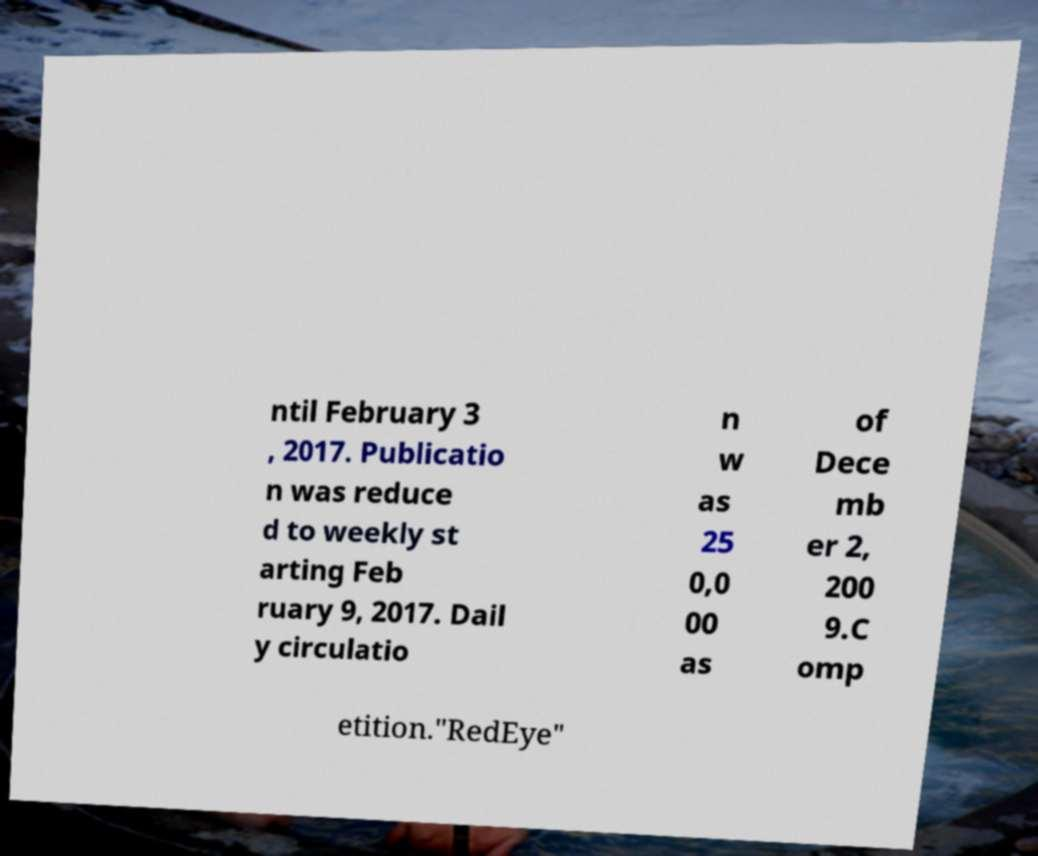For documentation purposes, I need the text within this image transcribed. Could you provide that? ntil February 3 , 2017. Publicatio n was reduce d to weekly st arting Feb ruary 9, 2017. Dail y circulatio n w as 25 0,0 00 as of Dece mb er 2, 200 9.C omp etition."RedEye" 